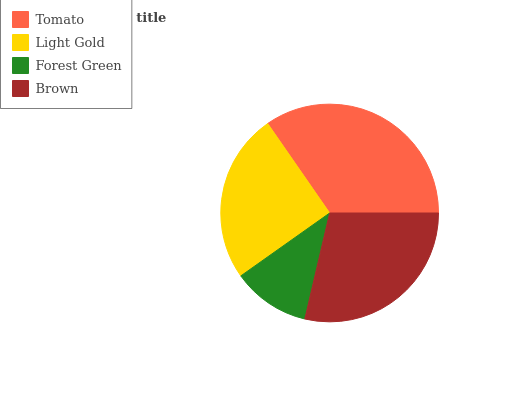Is Forest Green the minimum?
Answer yes or no. Yes. Is Tomato the maximum?
Answer yes or no. Yes. Is Light Gold the minimum?
Answer yes or no. No. Is Light Gold the maximum?
Answer yes or no. No. Is Tomato greater than Light Gold?
Answer yes or no. Yes. Is Light Gold less than Tomato?
Answer yes or no. Yes. Is Light Gold greater than Tomato?
Answer yes or no. No. Is Tomato less than Light Gold?
Answer yes or no. No. Is Brown the high median?
Answer yes or no. Yes. Is Light Gold the low median?
Answer yes or no. Yes. Is Light Gold the high median?
Answer yes or no. No. Is Forest Green the low median?
Answer yes or no. No. 